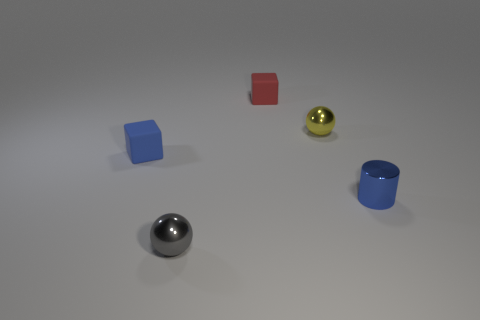Is the blue rubber block the same size as the red rubber object?
Give a very brief answer. Yes. There is a blue metallic cylinder; are there any tiny metallic things behind it?
Ensure brevity in your answer.  Yes. There is a object that is in front of the small blue matte thing and behind the gray ball; how big is it?
Offer a terse response. Small. How many things are either red things or large cyan cylinders?
Ensure brevity in your answer.  1. Does the blue cylinder have the same size as the sphere that is in front of the blue metal cylinder?
Provide a short and direct response. Yes. There is a sphere in front of the tiny matte object that is left of the rubber thing to the right of the tiny blue matte block; what size is it?
Your answer should be compact. Small. Are there any small matte cubes?
Your response must be concise. Yes. What is the material of the tiny thing that is the same color as the metallic cylinder?
Ensure brevity in your answer.  Rubber. What number of cubes are the same color as the metal cylinder?
Give a very brief answer. 1. What number of things are yellow metal balls that are right of the tiny red rubber thing or tiny yellow balls right of the blue block?
Provide a short and direct response. 1. 